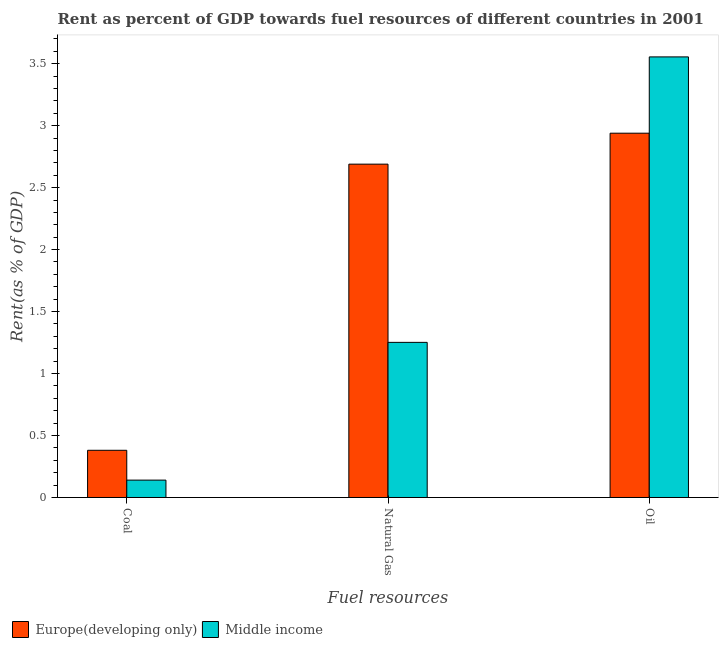How many groups of bars are there?
Your response must be concise. 3. Are the number of bars on each tick of the X-axis equal?
Offer a very short reply. Yes. How many bars are there on the 1st tick from the right?
Keep it short and to the point. 2. What is the label of the 3rd group of bars from the left?
Keep it short and to the point. Oil. What is the rent towards coal in Europe(developing only)?
Keep it short and to the point. 0.38. Across all countries, what is the maximum rent towards oil?
Ensure brevity in your answer.  3.55. Across all countries, what is the minimum rent towards natural gas?
Your answer should be compact. 1.25. In which country was the rent towards coal maximum?
Provide a succinct answer. Europe(developing only). In which country was the rent towards oil minimum?
Your response must be concise. Europe(developing only). What is the total rent towards coal in the graph?
Provide a short and direct response. 0.52. What is the difference between the rent towards natural gas in Middle income and that in Europe(developing only)?
Your response must be concise. -1.44. What is the difference between the rent towards coal in Europe(developing only) and the rent towards oil in Middle income?
Make the answer very short. -3.17. What is the average rent towards coal per country?
Your response must be concise. 0.26. What is the difference between the rent towards natural gas and rent towards oil in Middle income?
Your answer should be compact. -2.3. In how many countries, is the rent towards natural gas greater than 0.6 %?
Make the answer very short. 2. What is the ratio of the rent towards oil in Middle income to that in Europe(developing only)?
Your answer should be very brief. 1.21. Is the rent towards coal in Europe(developing only) less than that in Middle income?
Provide a short and direct response. No. What is the difference between the highest and the second highest rent towards coal?
Offer a terse response. 0.24. What is the difference between the highest and the lowest rent towards oil?
Your response must be concise. 0.62. In how many countries, is the rent towards natural gas greater than the average rent towards natural gas taken over all countries?
Provide a short and direct response. 1. What does the 2nd bar from the left in Oil represents?
Keep it short and to the point. Middle income. What does the 1st bar from the right in Natural Gas represents?
Keep it short and to the point. Middle income. Is it the case that in every country, the sum of the rent towards coal and rent towards natural gas is greater than the rent towards oil?
Provide a succinct answer. No. How many countries are there in the graph?
Offer a terse response. 2. What is the difference between two consecutive major ticks on the Y-axis?
Make the answer very short. 0.5. Where does the legend appear in the graph?
Offer a terse response. Bottom left. How are the legend labels stacked?
Keep it short and to the point. Horizontal. What is the title of the graph?
Make the answer very short. Rent as percent of GDP towards fuel resources of different countries in 2001. Does "Australia" appear as one of the legend labels in the graph?
Offer a very short reply. No. What is the label or title of the X-axis?
Make the answer very short. Fuel resources. What is the label or title of the Y-axis?
Offer a terse response. Rent(as % of GDP). What is the Rent(as % of GDP) in Europe(developing only) in Coal?
Offer a terse response. 0.38. What is the Rent(as % of GDP) in Middle income in Coal?
Your answer should be very brief. 0.14. What is the Rent(as % of GDP) in Europe(developing only) in Natural Gas?
Offer a very short reply. 2.69. What is the Rent(as % of GDP) of Middle income in Natural Gas?
Offer a very short reply. 1.25. What is the Rent(as % of GDP) of Europe(developing only) in Oil?
Offer a very short reply. 2.94. What is the Rent(as % of GDP) of Middle income in Oil?
Your response must be concise. 3.55. Across all Fuel resources, what is the maximum Rent(as % of GDP) of Europe(developing only)?
Provide a short and direct response. 2.94. Across all Fuel resources, what is the maximum Rent(as % of GDP) in Middle income?
Give a very brief answer. 3.55. Across all Fuel resources, what is the minimum Rent(as % of GDP) of Europe(developing only)?
Your response must be concise. 0.38. Across all Fuel resources, what is the minimum Rent(as % of GDP) in Middle income?
Your answer should be compact. 0.14. What is the total Rent(as % of GDP) in Europe(developing only) in the graph?
Keep it short and to the point. 6.01. What is the total Rent(as % of GDP) of Middle income in the graph?
Provide a succinct answer. 4.95. What is the difference between the Rent(as % of GDP) of Europe(developing only) in Coal and that in Natural Gas?
Keep it short and to the point. -2.31. What is the difference between the Rent(as % of GDP) of Middle income in Coal and that in Natural Gas?
Make the answer very short. -1.11. What is the difference between the Rent(as % of GDP) in Europe(developing only) in Coal and that in Oil?
Offer a terse response. -2.56. What is the difference between the Rent(as % of GDP) in Middle income in Coal and that in Oil?
Ensure brevity in your answer.  -3.41. What is the difference between the Rent(as % of GDP) in Europe(developing only) in Natural Gas and that in Oil?
Provide a short and direct response. -0.25. What is the difference between the Rent(as % of GDP) in Middle income in Natural Gas and that in Oil?
Offer a terse response. -2.3. What is the difference between the Rent(as % of GDP) in Europe(developing only) in Coal and the Rent(as % of GDP) in Middle income in Natural Gas?
Make the answer very short. -0.87. What is the difference between the Rent(as % of GDP) of Europe(developing only) in Coal and the Rent(as % of GDP) of Middle income in Oil?
Ensure brevity in your answer.  -3.17. What is the difference between the Rent(as % of GDP) in Europe(developing only) in Natural Gas and the Rent(as % of GDP) in Middle income in Oil?
Offer a very short reply. -0.87. What is the average Rent(as % of GDP) in Europe(developing only) per Fuel resources?
Ensure brevity in your answer.  2. What is the average Rent(as % of GDP) in Middle income per Fuel resources?
Ensure brevity in your answer.  1.65. What is the difference between the Rent(as % of GDP) of Europe(developing only) and Rent(as % of GDP) of Middle income in Coal?
Offer a very short reply. 0.24. What is the difference between the Rent(as % of GDP) of Europe(developing only) and Rent(as % of GDP) of Middle income in Natural Gas?
Your answer should be very brief. 1.44. What is the difference between the Rent(as % of GDP) in Europe(developing only) and Rent(as % of GDP) in Middle income in Oil?
Your answer should be compact. -0.62. What is the ratio of the Rent(as % of GDP) in Europe(developing only) in Coal to that in Natural Gas?
Your answer should be very brief. 0.14. What is the ratio of the Rent(as % of GDP) in Middle income in Coal to that in Natural Gas?
Ensure brevity in your answer.  0.11. What is the ratio of the Rent(as % of GDP) of Europe(developing only) in Coal to that in Oil?
Provide a short and direct response. 0.13. What is the ratio of the Rent(as % of GDP) in Middle income in Coal to that in Oil?
Offer a very short reply. 0.04. What is the ratio of the Rent(as % of GDP) of Europe(developing only) in Natural Gas to that in Oil?
Give a very brief answer. 0.92. What is the ratio of the Rent(as % of GDP) in Middle income in Natural Gas to that in Oil?
Offer a very short reply. 0.35. What is the difference between the highest and the second highest Rent(as % of GDP) of Europe(developing only)?
Your answer should be very brief. 0.25. What is the difference between the highest and the second highest Rent(as % of GDP) of Middle income?
Provide a short and direct response. 2.3. What is the difference between the highest and the lowest Rent(as % of GDP) of Europe(developing only)?
Ensure brevity in your answer.  2.56. What is the difference between the highest and the lowest Rent(as % of GDP) in Middle income?
Ensure brevity in your answer.  3.41. 